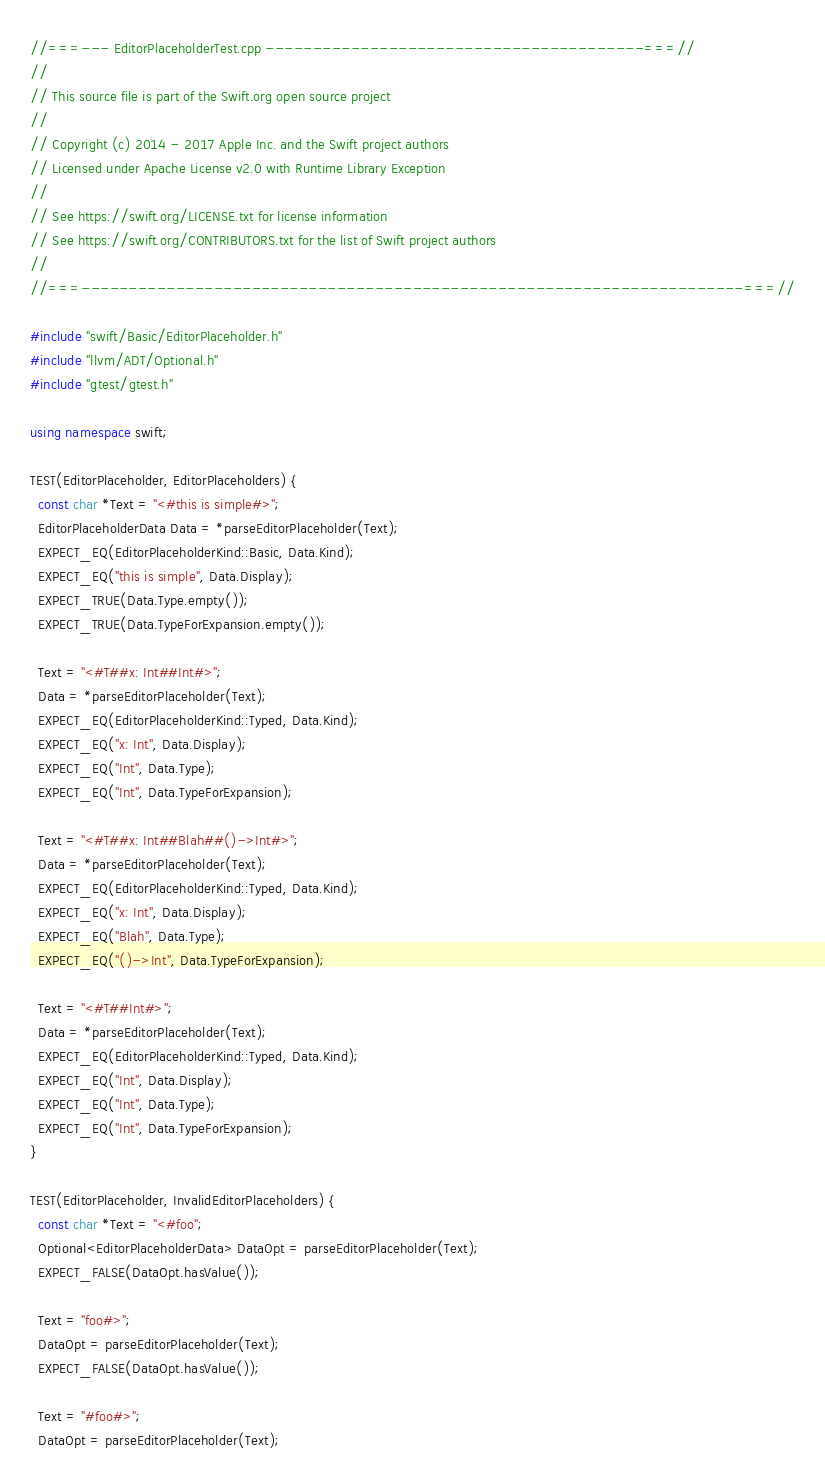<code> <loc_0><loc_0><loc_500><loc_500><_C++_>//===--- EditorPlaceholderTest.cpp ----------------------------------------===//
//
// This source file is part of the Swift.org open source project
//
// Copyright (c) 2014 - 2017 Apple Inc. and the Swift project authors
// Licensed under Apache License v2.0 with Runtime Library Exception
//
// See https://swift.org/LICENSE.txt for license information
// See https://swift.org/CONTRIBUTORS.txt for the list of Swift project authors
//
//===----------------------------------------------------------------------===//

#include "swift/Basic/EditorPlaceholder.h"
#include "llvm/ADT/Optional.h"
#include "gtest/gtest.h"

using namespace swift;

TEST(EditorPlaceholder, EditorPlaceholders) {
  const char *Text = "<#this is simple#>";
  EditorPlaceholderData Data = *parseEditorPlaceholder(Text);
  EXPECT_EQ(EditorPlaceholderKind::Basic, Data.Kind);
  EXPECT_EQ("this is simple", Data.Display);
  EXPECT_TRUE(Data.Type.empty());
  EXPECT_TRUE(Data.TypeForExpansion.empty());

  Text = "<#T##x: Int##Int#>";
  Data = *parseEditorPlaceholder(Text);
  EXPECT_EQ(EditorPlaceholderKind::Typed, Data.Kind);
  EXPECT_EQ("x: Int", Data.Display);
  EXPECT_EQ("Int", Data.Type);
  EXPECT_EQ("Int", Data.TypeForExpansion);

  Text = "<#T##x: Int##Blah##()->Int#>";
  Data = *parseEditorPlaceholder(Text);
  EXPECT_EQ(EditorPlaceholderKind::Typed, Data.Kind);
  EXPECT_EQ("x: Int", Data.Display);
  EXPECT_EQ("Blah", Data.Type);
  EXPECT_EQ("()->Int", Data.TypeForExpansion);

  Text = "<#T##Int#>";
  Data = *parseEditorPlaceholder(Text);
  EXPECT_EQ(EditorPlaceholderKind::Typed, Data.Kind);
  EXPECT_EQ("Int", Data.Display);
  EXPECT_EQ("Int", Data.Type);
  EXPECT_EQ("Int", Data.TypeForExpansion);
}

TEST(EditorPlaceholder, InvalidEditorPlaceholders) {
  const char *Text = "<#foo";
  Optional<EditorPlaceholderData> DataOpt = parseEditorPlaceholder(Text);
  EXPECT_FALSE(DataOpt.hasValue());

  Text = "foo#>";
  DataOpt = parseEditorPlaceholder(Text);
  EXPECT_FALSE(DataOpt.hasValue());

  Text = "#foo#>";
  DataOpt = parseEditorPlaceholder(Text);</code> 